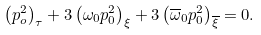Convert formula to latex. <formula><loc_0><loc_0><loc_500><loc_500>\left ( p _ { o } ^ { 2 } \right ) _ { \tau } + 3 \left ( \omega _ { 0 } p _ { 0 } ^ { 2 } \right ) _ { \xi } + 3 \left ( \overline { \omega } _ { 0 } p _ { 0 } ^ { 2 } \right ) _ { \overline { \xi } } = 0 .</formula> 